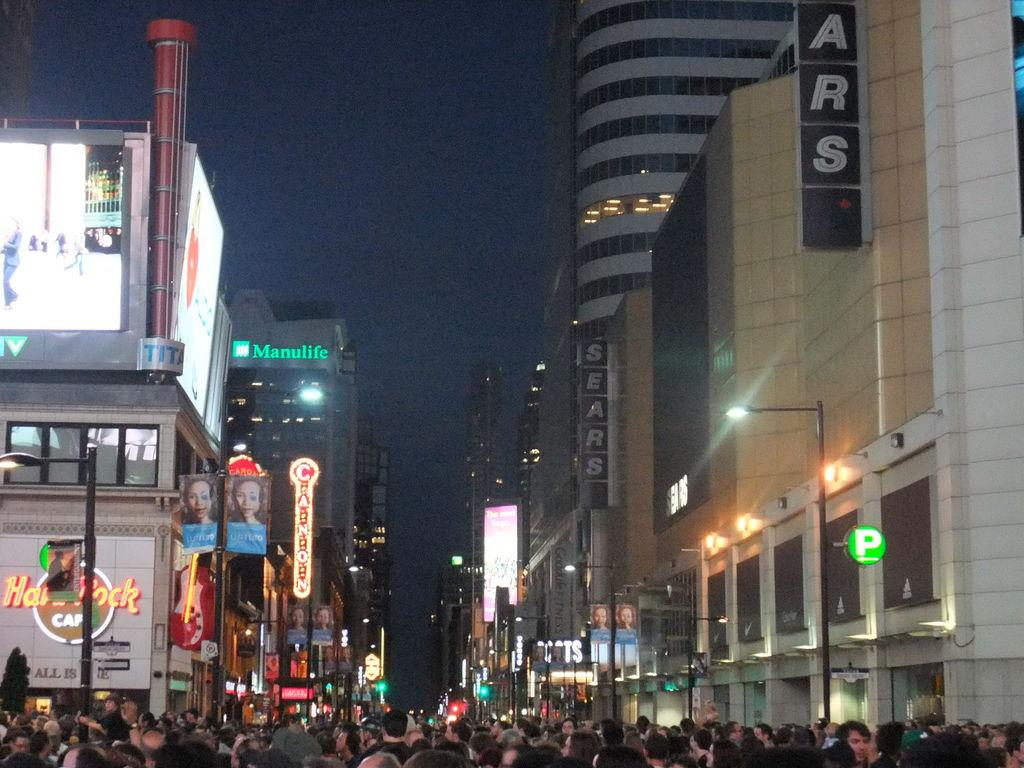<image>
Provide a brief description of the given image. a sears sign that is above the street at night 